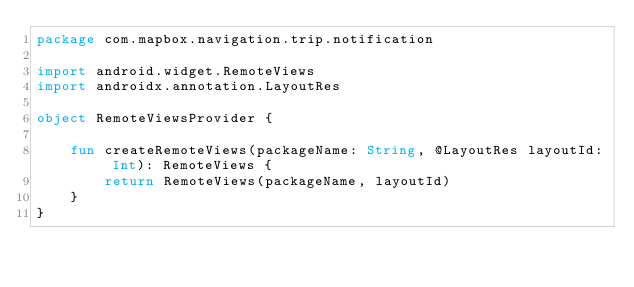Convert code to text. <code><loc_0><loc_0><loc_500><loc_500><_Kotlin_>package com.mapbox.navigation.trip.notification

import android.widget.RemoteViews
import androidx.annotation.LayoutRes

object RemoteViewsProvider {

    fun createRemoteViews(packageName: String, @LayoutRes layoutId: Int): RemoteViews {
        return RemoteViews(packageName, layoutId)
    }
}
</code> 